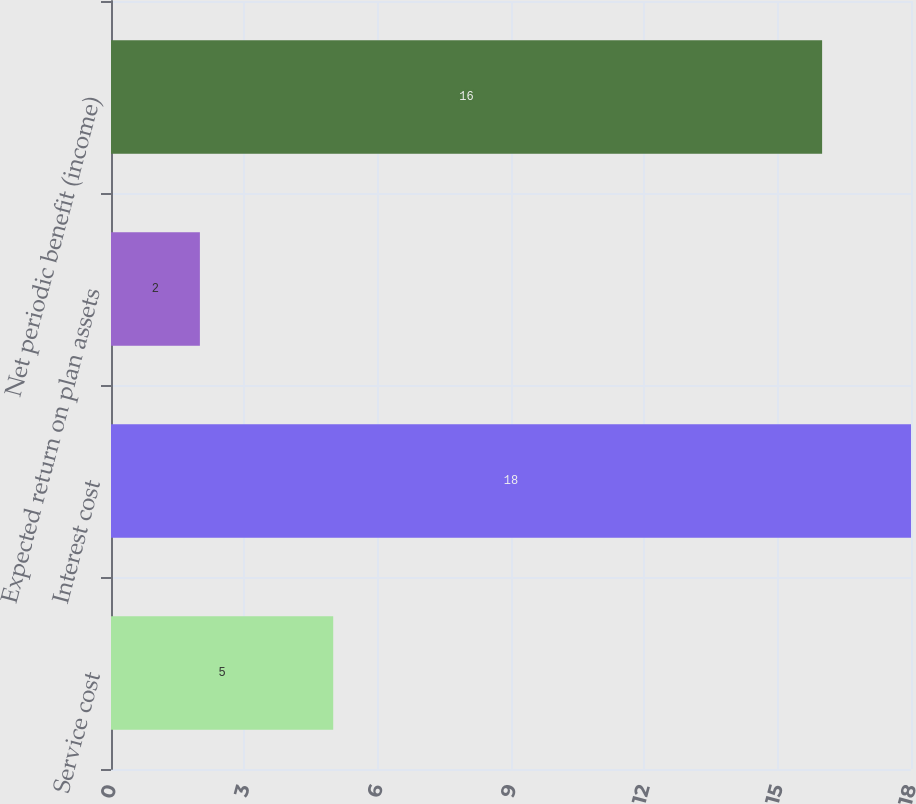<chart> <loc_0><loc_0><loc_500><loc_500><bar_chart><fcel>Service cost<fcel>Interest cost<fcel>Expected return on plan assets<fcel>Net periodic benefit (income)<nl><fcel>5<fcel>18<fcel>2<fcel>16<nl></chart> 